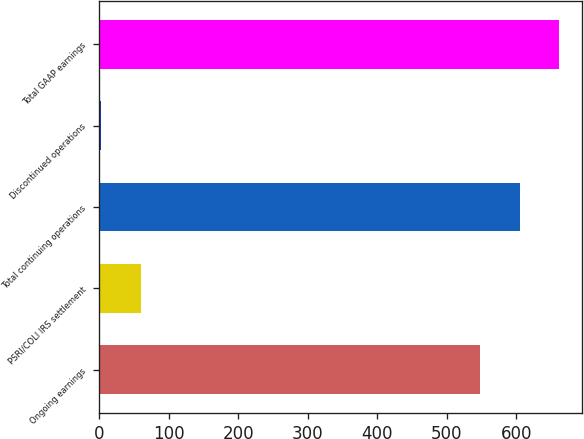<chart> <loc_0><loc_0><loc_500><loc_500><bar_chart><fcel>Ongoing earnings<fcel>PSRI/COLI IRS settlement<fcel>Total continuing operations<fcel>Discontinued operations<fcel>Total GAAP earnings<nl><fcel>548.2<fcel>59.97<fcel>605.07<fcel>3.1<fcel>661.94<nl></chart> 